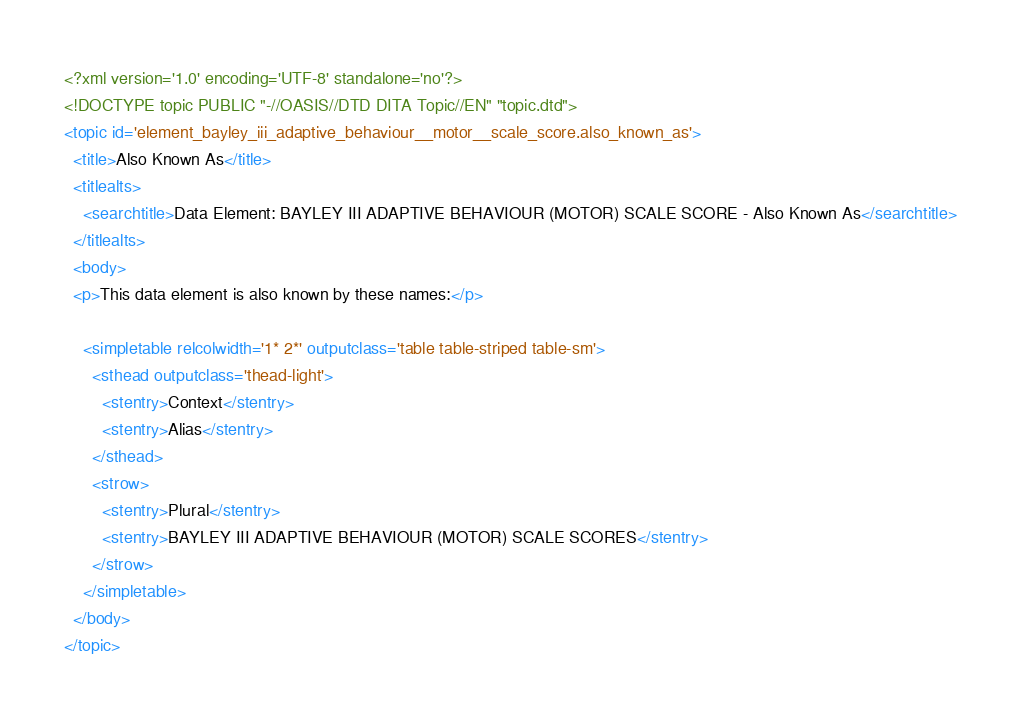<code> <loc_0><loc_0><loc_500><loc_500><_XML_><?xml version='1.0' encoding='UTF-8' standalone='no'?>
<!DOCTYPE topic PUBLIC "-//OASIS//DTD DITA Topic//EN" "topic.dtd">
<topic id='element_bayley_iii_adaptive_behaviour__motor__scale_score.also_known_as'>
  <title>Also Known As</title>
  <titlealts>
    <searchtitle>Data Element: BAYLEY III ADAPTIVE BEHAVIOUR (MOTOR) SCALE SCORE - Also Known As</searchtitle>
  </titlealts>
  <body>
  <p>This data element is also known by these names:</p>

    <simpletable relcolwidth='1* 2*' outputclass='table table-striped table-sm'>
      <sthead outputclass='thead-light'>
        <stentry>Context</stentry>
        <stentry>Alias</stentry>
      </sthead>
      <strow>
        <stentry>Plural</stentry>
        <stentry>BAYLEY III ADAPTIVE BEHAVIOUR (MOTOR) SCALE SCORES</stentry>
      </strow>
    </simpletable>
  </body>
</topic></code> 